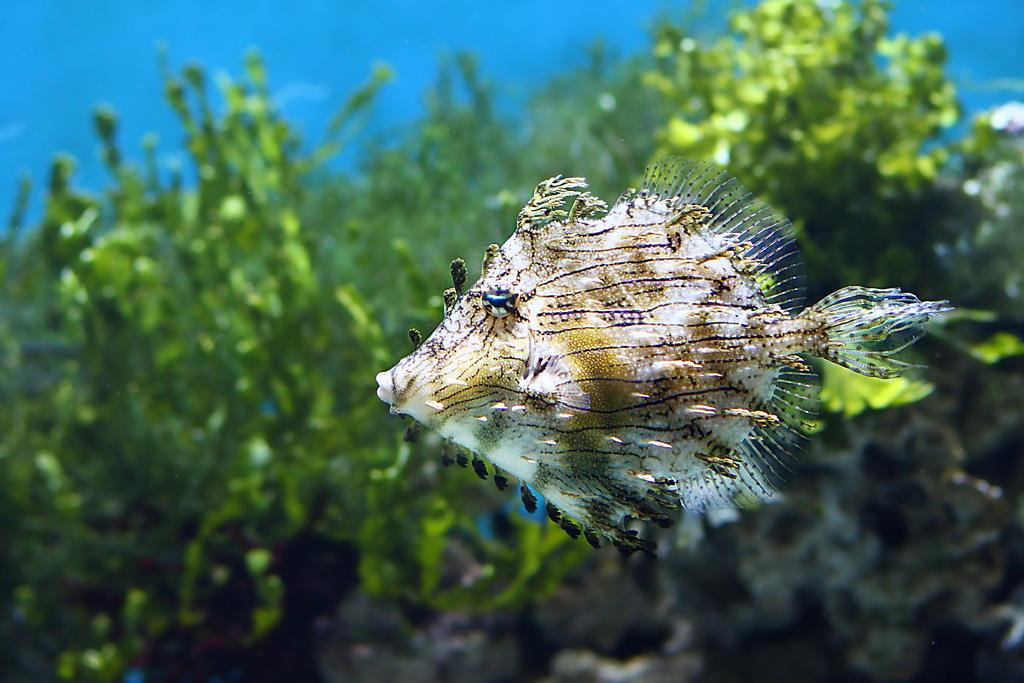What is the main subject in the foreground of the image? There is a fish in the foreground of the image. Where is the fish located? The fish is underwater. What can be seen in the background of the image? There are plants in the background of the image. What type of pear is hanging from the plants in the background? There is no pear present in the image; it features a fish underwater with plants in the background. 